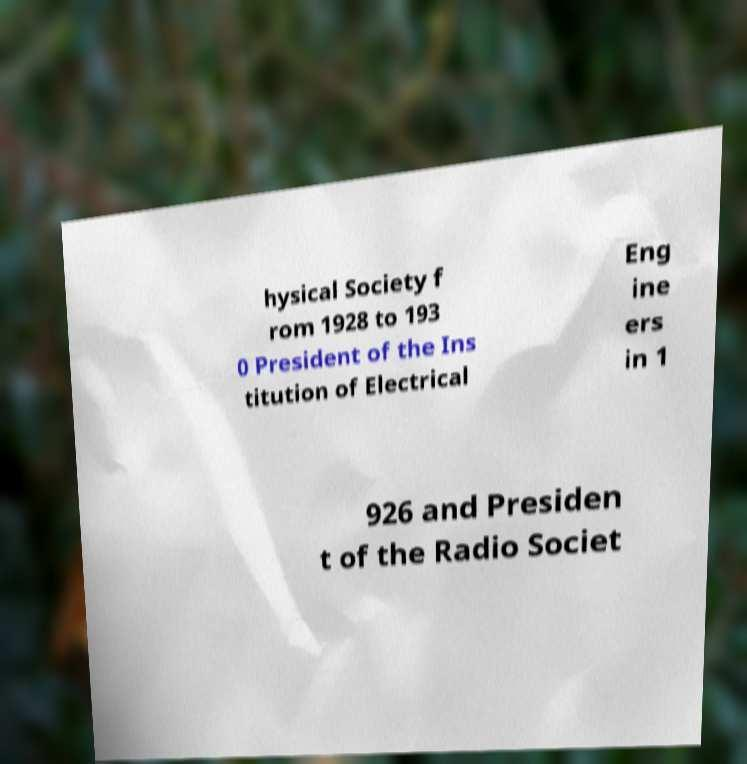There's text embedded in this image that I need extracted. Can you transcribe it verbatim? hysical Society f rom 1928 to 193 0 President of the Ins titution of Electrical Eng ine ers in 1 926 and Presiden t of the Radio Societ 